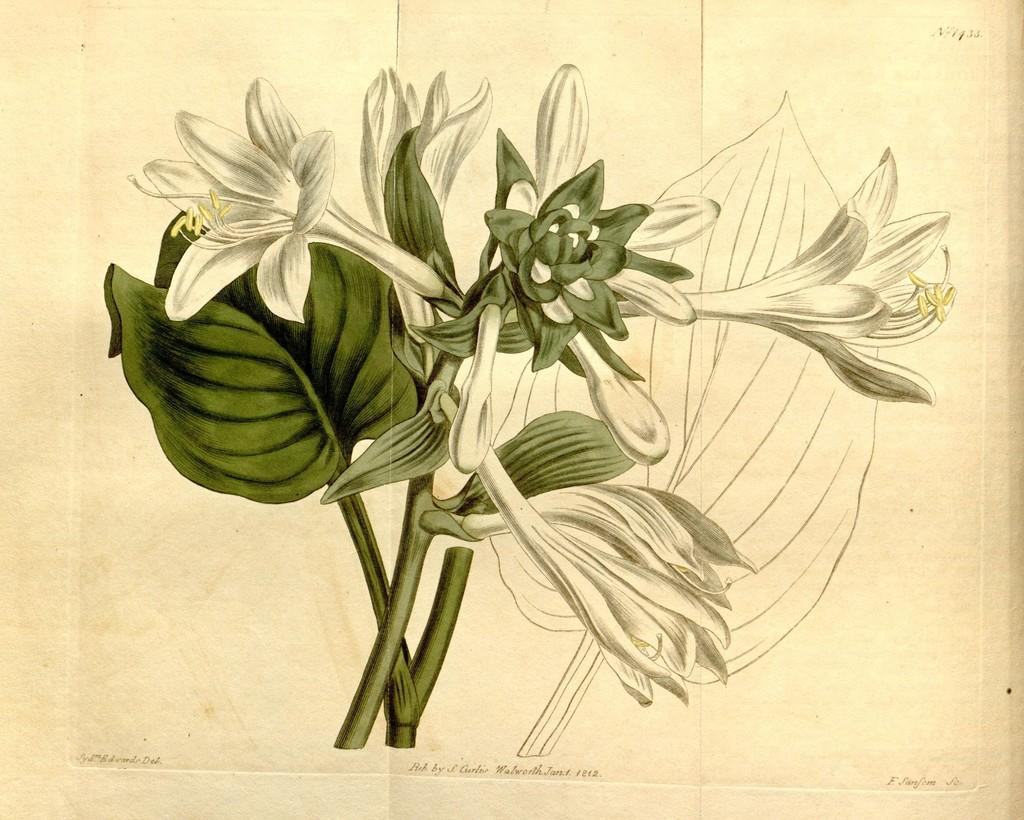What type of visual is the image? The image is a poster. What natural elements are depicted in the poster? There are leaves and flowers in the image. Is there any text present on the poster? Yes, there is text on the image. What type of jar is shown in the image? There is no jar present in the image; it features a poster with leaves, flowers, and text. What kind of pest can be seen crawling on the flowers in the image? There are no pests visible in the image; it only shows leaves, flowers, and text. 